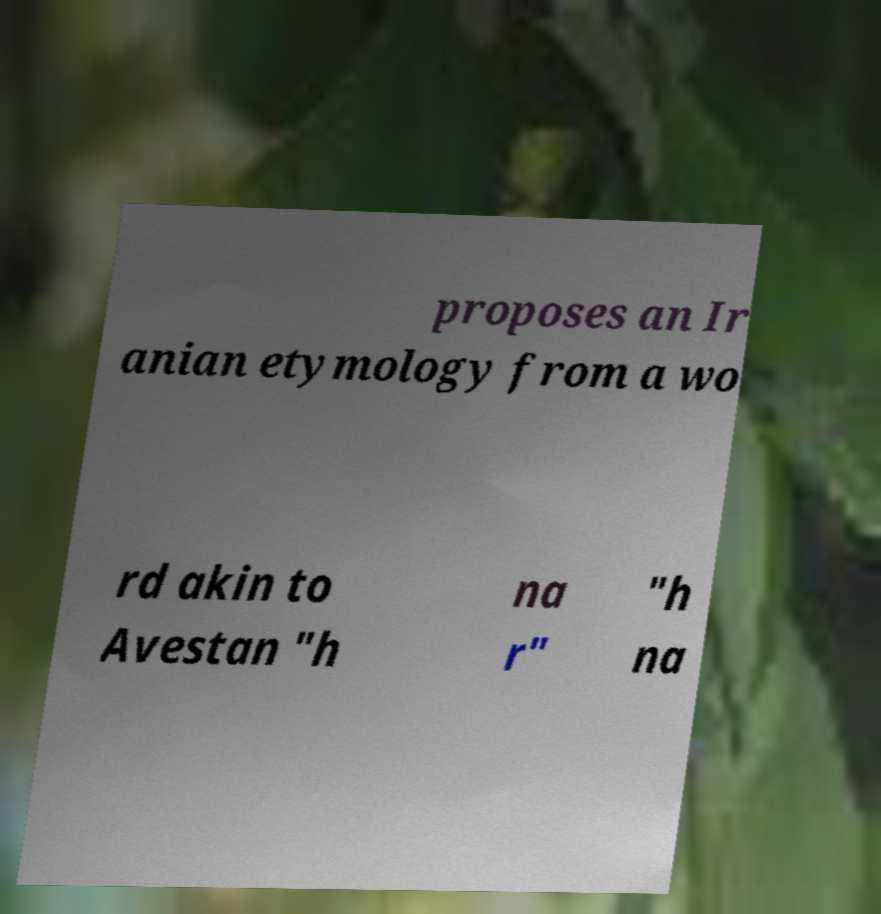Can you accurately transcribe the text from the provided image for me? proposes an Ir anian etymology from a wo rd akin to Avestan "h na r" "h na 